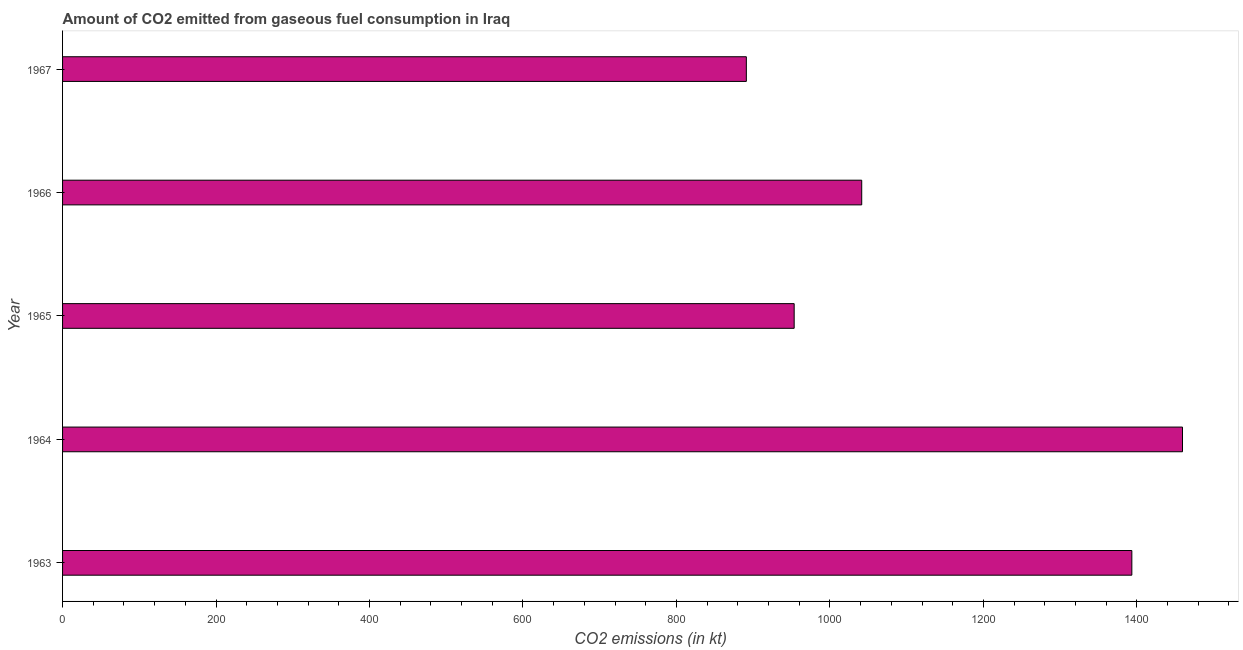Does the graph contain grids?
Ensure brevity in your answer.  No. What is the title of the graph?
Provide a succinct answer. Amount of CO2 emitted from gaseous fuel consumption in Iraq. What is the label or title of the X-axis?
Make the answer very short. CO2 emissions (in kt). What is the label or title of the Y-axis?
Your answer should be compact. Year. What is the co2 emissions from gaseous fuel consumption in 1964?
Offer a very short reply. 1459.47. Across all years, what is the maximum co2 emissions from gaseous fuel consumption?
Offer a terse response. 1459.47. Across all years, what is the minimum co2 emissions from gaseous fuel consumption?
Give a very brief answer. 891.08. In which year was the co2 emissions from gaseous fuel consumption maximum?
Your answer should be compact. 1964. In which year was the co2 emissions from gaseous fuel consumption minimum?
Ensure brevity in your answer.  1967. What is the sum of the co2 emissions from gaseous fuel consumption?
Keep it short and to the point. 5738.86. What is the difference between the co2 emissions from gaseous fuel consumption in 1963 and 1966?
Give a very brief answer. 352.03. What is the average co2 emissions from gaseous fuel consumption per year?
Offer a very short reply. 1147.77. What is the median co2 emissions from gaseous fuel consumption?
Make the answer very short. 1041.43. In how many years, is the co2 emissions from gaseous fuel consumption greater than 760 kt?
Your answer should be very brief. 5. What is the ratio of the co2 emissions from gaseous fuel consumption in 1965 to that in 1967?
Provide a short and direct response. 1.07. Is the difference between the co2 emissions from gaseous fuel consumption in 1964 and 1967 greater than the difference between any two years?
Your answer should be very brief. Yes. What is the difference between the highest and the second highest co2 emissions from gaseous fuel consumption?
Keep it short and to the point. 66.01. Is the sum of the co2 emissions from gaseous fuel consumption in 1963 and 1964 greater than the maximum co2 emissions from gaseous fuel consumption across all years?
Ensure brevity in your answer.  Yes. What is the difference between the highest and the lowest co2 emissions from gaseous fuel consumption?
Offer a very short reply. 568.38. How many bars are there?
Keep it short and to the point. 5. What is the CO2 emissions (in kt) of 1963?
Provide a succinct answer. 1393.46. What is the CO2 emissions (in kt) in 1964?
Keep it short and to the point. 1459.47. What is the CO2 emissions (in kt) in 1965?
Your answer should be compact. 953.42. What is the CO2 emissions (in kt) in 1966?
Give a very brief answer. 1041.43. What is the CO2 emissions (in kt) of 1967?
Ensure brevity in your answer.  891.08. What is the difference between the CO2 emissions (in kt) in 1963 and 1964?
Provide a short and direct response. -66.01. What is the difference between the CO2 emissions (in kt) in 1963 and 1965?
Your answer should be compact. 440.04. What is the difference between the CO2 emissions (in kt) in 1963 and 1966?
Offer a very short reply. 352.03. What is the difference between the CO2 emissions (in kt) in 1963 and 1967?
Make the answer very short. 502.38. What is the difference between the CO2 emissions (in kt) in 1964 and 1965?
Your answer should be very brief. 506.05. What is the difference between the CO2 emissions (in kt) in 1964 and 1966?
Offer a very short reply. 418.04. What is the difference between the CO2 emissions (in kt) in 1964 and 1967?
Provide a succinct answer. 568.38. What is the difference between the CO2 emissions (in kt) in 1965 and 1966?
Give a very brief answer. -88.01. What is the difference between the CO2 emissions (in kt) in 1965 and 1967?
Give a very brief answer. 62.34. What is the difference between the CO2 emissions (in kt) in 1966 and 1967?
Provide a short and direct response. 150.35. What is the ratio of the CO2 emissions (in kt) in 1963 to that in 1964?
Give a very brief answer. 0.95. What is the ratio of the CO2 emissions (in kt) in 1963 to that in 1965?
Ensure brevity in your answer.  1.46. What is the ratio of the CO2 emissions (in kt) in 1963 to that in 1966?
Your answer should be compact. 1.34. What is the ratio of the CO2 emissions (in kt) in 1963 to that in 1967?
Keep it short and to the point. 1.56. What is the ratio of the CO2 emissions (in kt) in 1964 to that in 1965?
Your response must be concise. 1.53. What is the ratio of the CO2 emissions (in kt) in 1964 to that in 1966?
Offer a terse response. 1.4. What is the ratio of the CO2 emissions (in kt) in 1964 to that in 1967?
Your answer should be very brief. 1.64. What is the ratio of the CO2 emissions (in kt) in 1965 to that in 1966?
Ensure brevity in your answer.  0.92. What is the ratio of the CO2 emissions (in kt) in 1965 to that in 1967?
Provide a short and direct response. 1.07. What is the ratio of the CO2 emissions (in kt) in 1966 to that in 1967?
Offer a terse response. 1.17. 